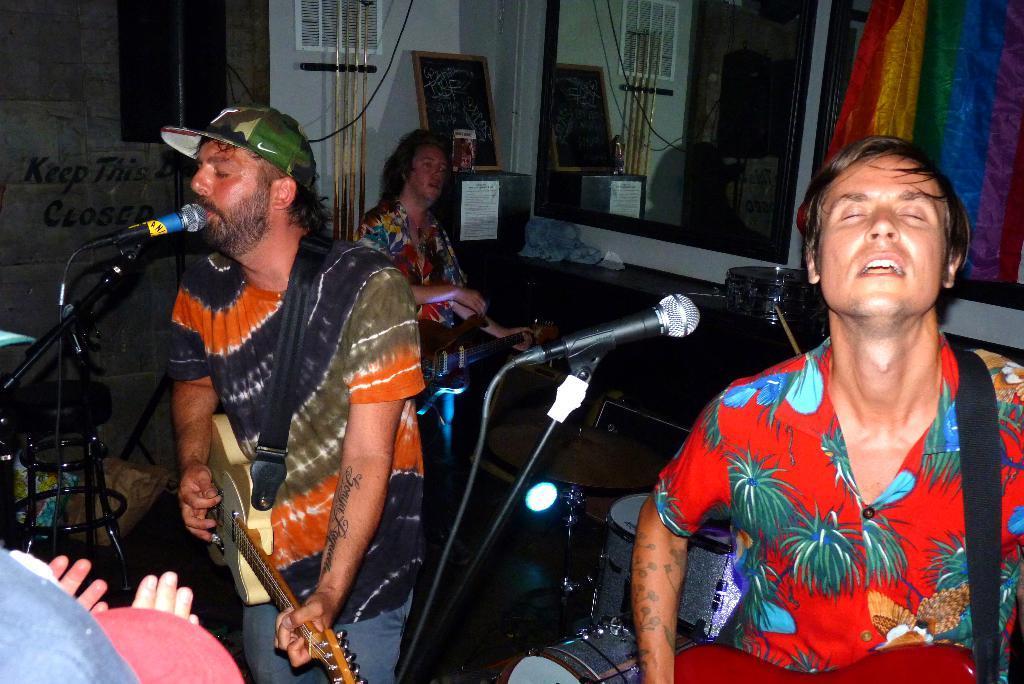In one or two sentences, can you explain what this image depicts? On the background we can see windows, curtain. here we can see a wall and a table and on the table there is a photo frame. Here we can see a table and on the table we can see drums. Here we can see two persons standing in front of a mike and playing guitar and singing. On the background we can see other person playing guitar. 